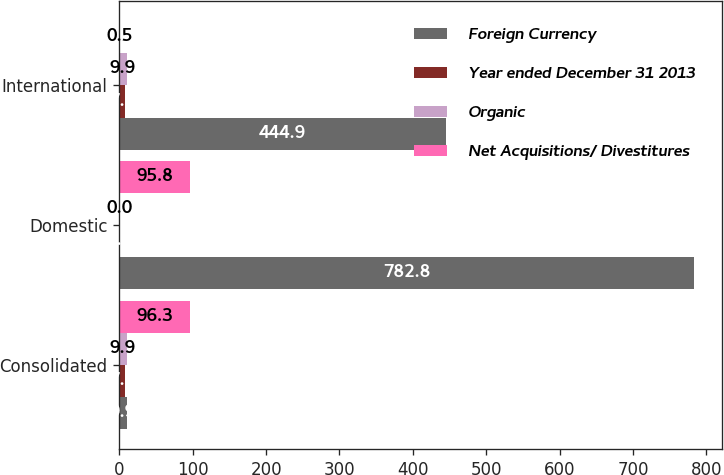<chart> <loc_0><loc_0><loc_500><loc_500><stacked_bar_chart><ecel><fcel>Consolidated<fcel>Domestic<fcel>International<nl><fcel>Foreign Currency<fcel>9.9<fcel>782.8<fcel>444.9<nl><fcel>Year ended December 31 2013<fcel>7.2<fcel>0<fcel>7.2<nl><fcel>Organic<fcel>9.9<fcel>0<fcel>9.9<nl><fcel>Net Acquisitions/ Divestitures<fcel>96.3<fcel>95.8<fcel>0.5<nl></chart> 